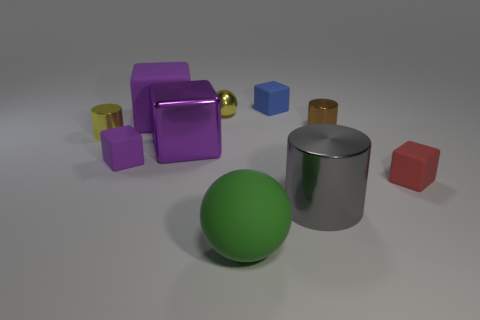The block that is both left of the red thing and right of the tiny shiny ball is what color?
Give a very brief answer. Blue. How many big objects are either yellow metal spheres or purple matte objects?
Your answer should be very brief. 1. The other metallic thing that is the same shape as the red thing is what size?
Your answer should be very brief. Large. The big green object is what shape?
Provide a succinct answer. Sphere. Is the tiny purple thing made of the same material as the cylinder that is in front of the tiny red block?
Offer a very short reply. No. What number of metal objects are either tiny gray cylinders or tiny spheres?
Your response must be concise. 1. How big is the cylinder in front of the tiny purple block?
Keep it short and to the point. Large. What is the size of the cube that is made of the same material as the big gray cylinder?
Provide a short and direct response. Large. How many cylinders are the same color as the small metallic ball?
Your answer should be compact. 1. Are there any yellow objects?
Provide a succinct answer. Yes. 